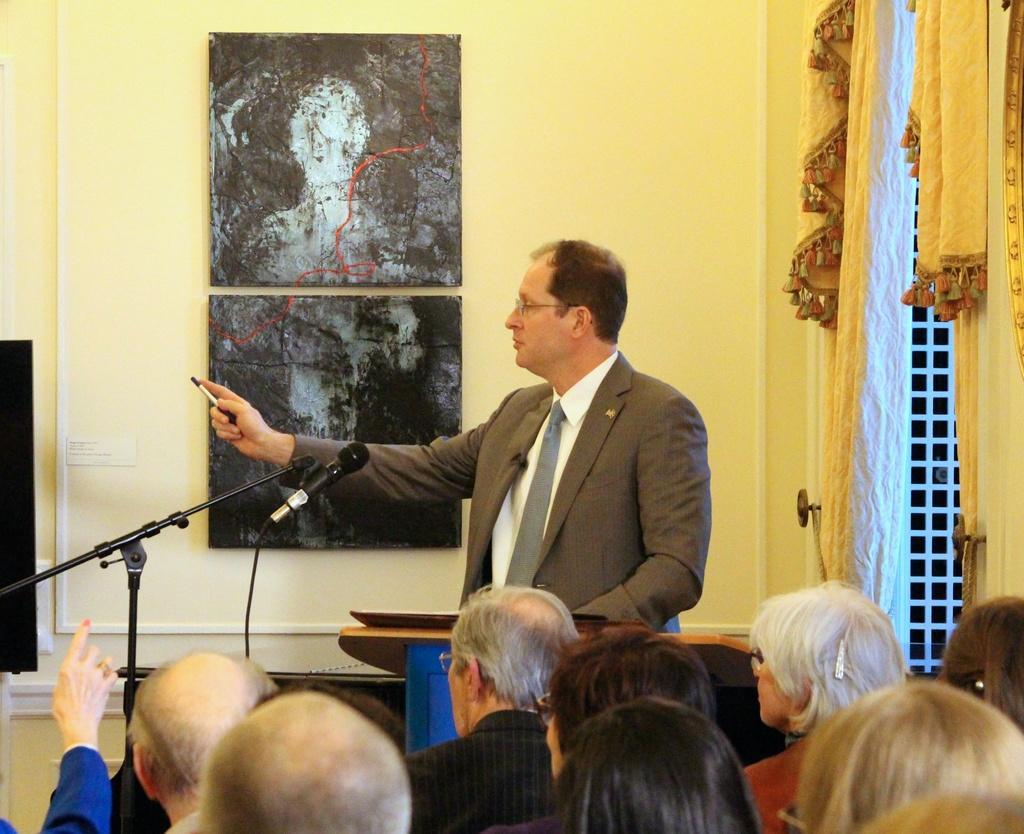How would you summarize this image in a sentence or two? In this image I can see few people and one person is standing in-front of the podium. I can see the mic, stand, curtain and few frames are attached to the wall. 